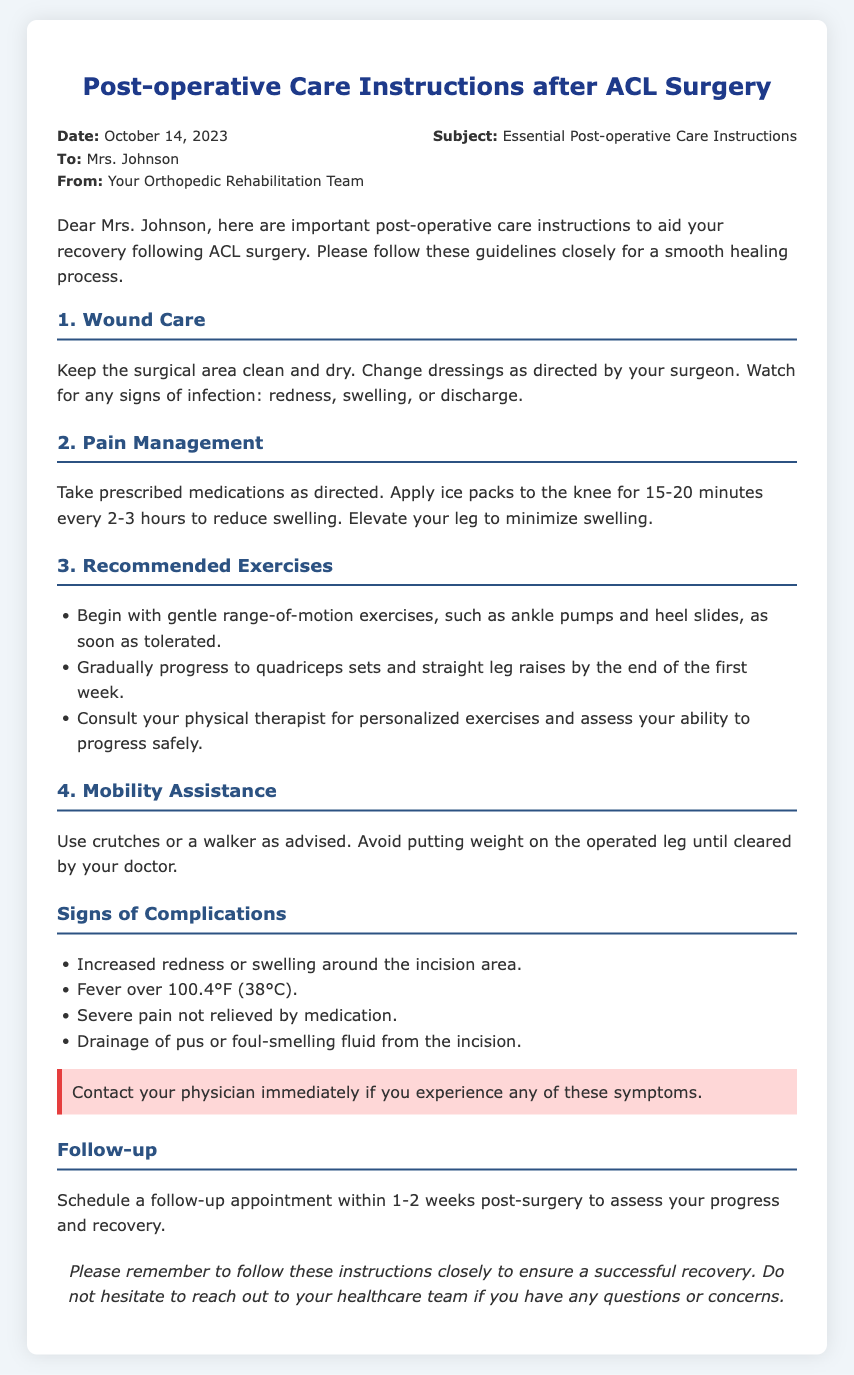What is the date of the memo? The date of the memo is found in the header section of the document, indicating when it was issued.
Answer: October 14, 2023 Who is the memo addressed to? The recipient's name is mentioned in the header of the memo, indicating to whom the instructions are directed.
Answer: Mrs. Johnson What should you do if you notice increased redness or swelling around the incision? This is a warning provided in the document, highlighting what actions to take if a specific symptom occurs.
Answer: Contact your physician immediately How often should ice packs be applied to the knee? The document provides a specific time frame for applying ice, which is crucial for managing swelling post-surgery.
Answer: Every 2-3 hours What is the first type of exercise recommended after surgery? The document lists the first recommended exercise as part of the recovery process, indicating where to start following surgery.
Answer: Ankle pumps When should you schedule a follow-up appointment after surgery? The document specifies a time frame for scheduling a follow-up, which is important for ongoing care.
Answer: Within 1-2 weeks 